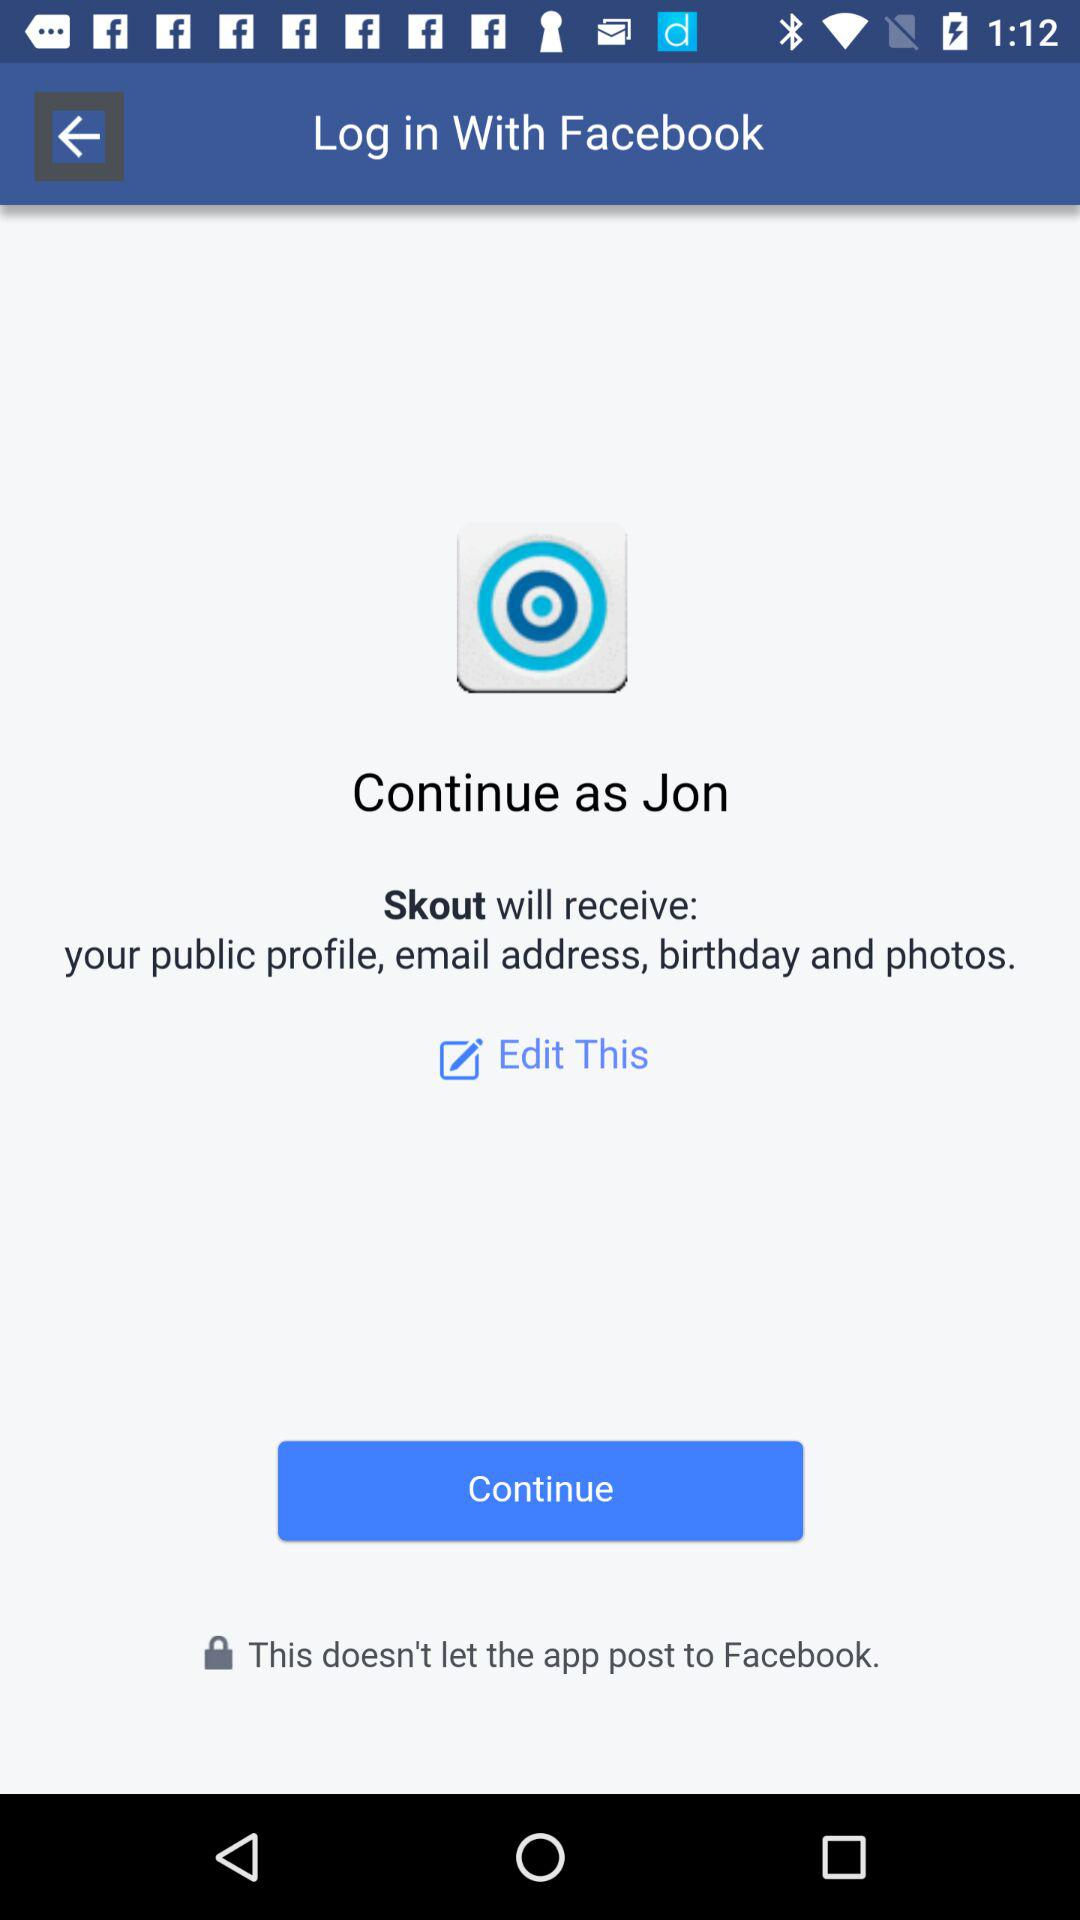What application is asking for access? The application asking for access is "Skout". 